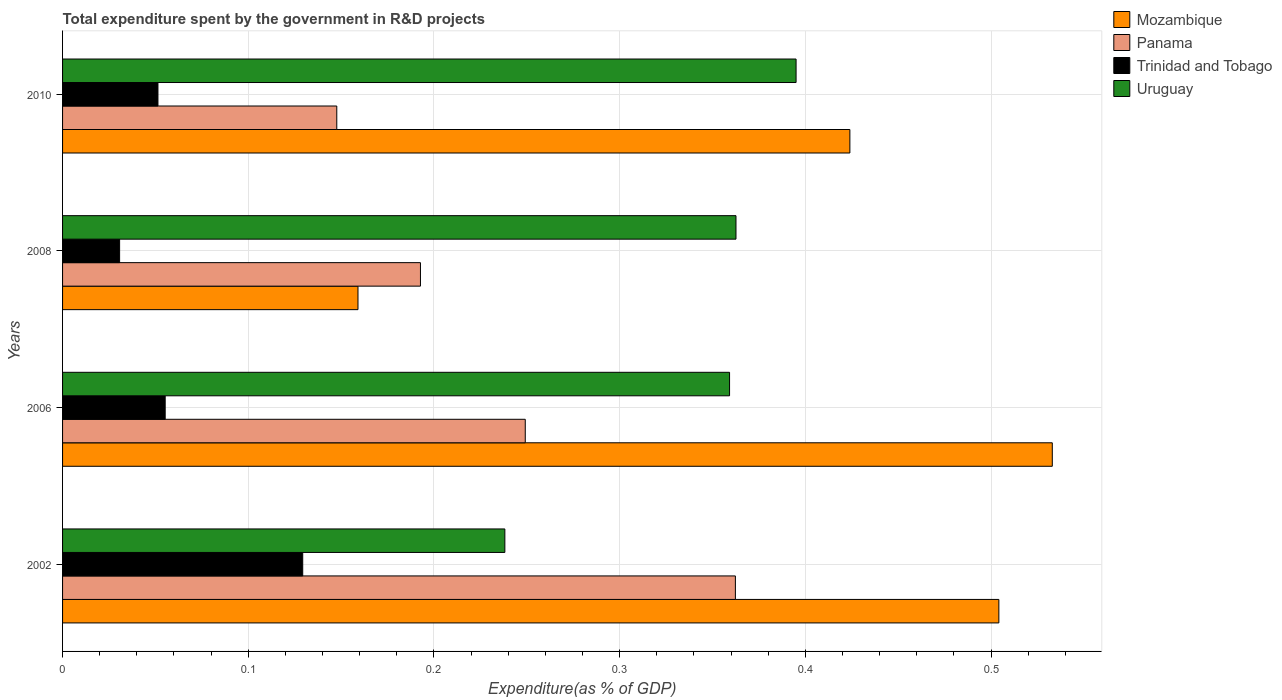How many different coloured bars are there?
Offer a very short reply. 4. Are the number of bars per tick equal to the number of legend labels?
Your response must be concise. Yes. How many bars are there on the 3rd tick from the top?
Offer a terse response. 4. How many bars are there on the 2nd tick from the bottom?
Provide a short and direct response. 4. What is the label of the 4th group of bars from the top?
Your answer should be compact. 2002. In how many cases, is the number of bars for a given year not equal to the number of legend labels?
Keep it short and to the point. 0. What is the total expenditure spent by the government in R&D projects in Mozambique in 2002?
Ensure brevity in your answer.  0.5. Across all years, what is the maximum total expenditure spent by the government in R&D projects in Trinidad and Tobago?
Keep it short and to the point. 0.13. Across all years, what is the minimum total expenditure spent by the government in R&D projects in Uruguay?
Your response must be concise. 0.24. In which year was the total expenditure spent by the government in R&D projects in Panama minimum?
Keep it short and to the point. 2010. What is the total total expenditure spent by the government in R&D projects in Trinidad and Tobago in the graph?
Your response must be concise. 0.27. What is the difference between the total expenditure spent by the government in R&D projects in Mozambique in 2002 and that in 2006?
Your answer should be compact. -0.03. What is the difference between the total expenditure spent by the government in R&D projects in Uruguay in 2010 and the total expenditure spent by the government in R&D projects in Mozambique in 2008?
Provide a succinct answer. 0.24. What is the average total expenditure spent by the government in R&D projects in Mozambique per year?
Offer a very short reply. 0.41. In the year 2008, what is the difference between the total expenditure spent by the government in R&D projects in Uruguay and total expenditure spent by the government in R&D projects in Panama?
Offer a terse response. 0.17. In how many years, is the total expenditure spent by the government in R&D projects in Panama greater than 0.06 %?
Your response must be concise. 4. What is the ratio of the total expenditure spent by the government in R&D projects in Mozambique in 2002 to that in 2010?
Give a very brief answer. 1.19. What is the difference between the highest and the second highest total expenditure spent by the government in R&D projects in Mozambique?
Make the answer very short. 0.03. What is the difference between the highest and the lowest total expenditure spent by the government in R&D projects in Uruguay?
Your answer should be very brief. 0.16. What does the 3rd bar from the top in 2002 represents?
Make the answer very short. Panama. What does the 2nd bar from the bottom in 2008 represents?
Your answer should be compact. Panama. How many bars are there?
Your answer should be very brief. 16. Are all the bars in the graph horizontal?
Your response must be concise. Yes. How many years are there in the graph?
Give a very brief answer. 4. What is the difference between two consecutive major ticks on the X-axis?
Provide a short and direct response. 0.1. Are the values on the major ticks of X-axis written in scientific E-notation?
Make the answer very short. No. Does the graph contain grids?
Your answer should be very brief. Yes. What is the title of the graph?
Keep it short and to the point. Total expenditure spent by the government in R&D projects. What is the label or title of the X-axis?
Your answer should be very brief. Expenditure(as % of GDP). What is the label or title of the Y-axis?
Ensure brevity in your answer.  Years. What is the Expenditure(as % of GDP) in Mozambique in 2002?
Keep it short and to the point. 0.5. What is the Expenditure(as % of GDP) of Panama in 2002?
Make the answer very short. 0.36. What is the Expenditure(as % of GDP) of Trinidad and Tobago in 2002?
Give a very brief answer. 0.13. What is the Expenditure(as % of GDP) of Uruguay in 2002?
Make the answer very short. 0.24. What is the Expenditure(as % of GDP) in Mozambique in 2006?
Make the answer very short. 0.53. What is the Expenditure(as % of GDP) of Panama in 2006?
Make the answer very short. 0.25. What is the Expenditure(as % of GDP) in Trinidad and Tobago in 2006?
Your response must be concise. 0.06. What is the Expenditure(as % of GDP) in Uruguay in 2006?
Offer a very short reply. 0.36. What is the Expenditure(as % of GDP) of Mozambique in 2008?
Make the answer very short. 0.16. What is the Expenditure(as % of GDP) of Panama in 2008?
Give a very brief answer. 0.19. What is the Expenditure(as % of GDP) of Trinidad and Tobago in 2008?
Make the answer very short. 0.03. What is the Expenditure(as % of GDP) of Uruguay in 2008?
Your response must be concise. 0.36. What is the Expenditure(as % of GDP) of Mozambique in 2010?
Provide a short and direct response. 0.42. What is the Expenditure(as % of GDP) in Panama in 2010?
Offer a terse response. 0.15. What is the Expenditure(as % of GDP) of Trinidad and Tobago in 2010?
Offer a very short reply. 0.05. What is the Expenditure(as % of GDP) of Uruguay in 2010?
Make the answer very short. 0.4. Across all years, what is the maximum Expenditure(as % of GDP) in Mozambique?
Your response must be concise. 0.53. Across all years, what is the maximum Expenditure(as % of GDP) in Panama?
Give a very brief answer. 0.36. Across all years, what is the maximum Expenditure(as % of GDP) in Trinidad and Tobago?
Give a very brief answer. 0.13. Across all years, what is the maximum Expenditure(as % of GDP) of Uruguay?
Provide a short and direct response. 0.4. Across all years, what is the minimum Expenditure(as % of GDP) of Mozambique?
Make the answer very short. 0.16. Across all years, what is the minimum Expenditure(as % of GDP) in Panama?
Keep it short and to the point. 0.15. Across all years, what is the minimum Expenditure(as % of GDP) in Trinidad and Tobago?
Provide a short and direct response. 0.03. Across all years, what is the minimum Expenditure(as % of GDP) in Uruguay?
Provide a short and direct response. 0.24. What is the total Expenditure(as % of GDP) of Mozambique in the graph?
Keep it short and to the point. 1.62. What is the total Expenditure(as % of GDP) of Panama in the graph?
Ensure brevity in your answer.  0.95. What is the total Expenditure(as % of GDP) of Trinidad and Tobago in the graph?
Offer a terse response. 0.27. What is the total Expenditure(as % of GDP) of Uruguay in the graph?
Give a very brief answer. 1.35. What is the difference between the Expenditure(as % of GDP) in Mozambique in 2002 and that in 2006?
Give a very brief answer. -0.03. What is the difference between the Expenditure(as % of GDP) of Panama in 2002 and that in 2006?
Your response must be concise. 0.11. What is the difference between the Expenditure(as % of GDP) in Trinidad and Tobago in 2002 and that in 2006?
Keep it short and to the point. 0.07. What is the difference between the Expenditure(as % of GDP) of Uruguay in 2002 and that in 2006?
Keep it short and to the point. -0.12. What is the difference between the Expenditure(as % of GDP) of Mozambique in 2002 and that in 2008?
Your answer should be very brief. 0.35. What is the difference between the Expenditure(as % of GDP) of Panama in 2002 and that in 2008?
Offer a very short reply. 0.17. What is the difference between the Expenditure(as % of GDP) in Trinidad and Tobago in 2002 and that in 2008?
Your answer should be compact. 0.1. What is the difference between the Expenditure(as % of GDP) of Uruguay in 2002 and that in 2008?
Your response must be concise. -0.12. What is the difference between the Expenditure(as % of GDP) in Mozambique in 2002 and that in 2010?
Make the answer very short. 0.08. What is the difference between the Expenditure(as % of GDP) in Panama in 2002 and that in 2010?
Provide a short and direct response. 0.21. What is the difference between the Expenditure(as % of GDP) in Trinidad and Tobago in 2002 and that in 2010?
Provide a short and direct response. 0.08. What is the difference between the Expenditure(as % of GDP) of Uruguay in 2002 and that in 2010?
Give a very brief answer. -0.16. What is the difference between the Expenditure(as % of GDP) in Mozambique in 2006 and that in 2008?
Make the answer very short. 0.37. What is the difference between the Expenditure(as % of GDP) in Panama in 2006 and that in 2008?
Provide a short and direct response. 0.06. What is the difference between the Expenditure(as % of GDP) of Trinidad and Tobago in 2006 and that in 2008?
Your response must be concise. 0.02. What is the difference between the Expenditure(as % of GDP) of Uruguay in 2006 and that in 2008?
Your answer should be compact. -0. What is the difference between the Expenditure(as % of GDP) in Mozambique in 2006 and that in 2010?
Your response must be concise. 0.11. What is the difference between the Expenditure(as % of GDP) of Panama in 2006 and that in 2010?
Offer a terse response. 0.1. What is the difference between the Expenditure(as % of GDP) of Trinidad and Tobago in 2006 and that in 2010?
Your response must be concise. 0. What is the difference between the Expenditure(as % of GDP) in Uruguay in 2006 and that in 2010?
Your response must be concise. -0.04. What is the difference between the Expenditure(as % of GDP) of Mozambique in 2008 and that in 2010?
Ensure brevity in your answer.  -0.26. What is the difference between the Expenditure(as % of GDP) in Panama in 2008 and that in 2010?
Provide a succinct answer. 0.05. What is the difference between the Expenditure(as % of GDP) in Trinidad and Tobago in 2008 and that in 2010?
Provide a succinct answer. -0.02. What is the difference between the Expenditure(as % of GDP) in Uruguay in 2008 and that in 2010?
Ensure brevity in your answer.  -0.03. What is the difference between the Expenditure(as % of GDP) of Mozambique in 2002 and the Expenditure(as % of GDP) of Panama in 2006?
Provide a short and direct response. 0.26. What is the difference between the Expenditure(as % of GDP) of Mozambique in 2002 and the Expenditure(as % of GDP) of Trinidad and Tobago in 2006?
Make the answer very short. 0.45. What is the difference between the Expenditure(as % of GDP) of Mozambique in 2002 and the Expenditure(as % of GDP) of Uruguay in 2006?
Your response must be concise. 0.14. What is the difference between the Expenditure(as % of GDP) of Panama in 2002 and the Expenditure(as % of GDP) of Trinidad and Tobago in 2006?
Provide a succinct answer. 0.31. What is the difference between the Expenditure(as % of GDP) in Panama in 2002 and the Expenditure(as % of GDP) in Uruguay in 2006?
Keep it short and to the point. 0. What is the difference between the Expenditure(as % of GDP) in Trinidad and Tobago in 2002 and the Expenditure(as % of GDP) in Uruguay in 2006?
Provide a succinct answer. -0.23. What is the difference between the Expenditure(as % of GDP) in Mozambique in 2002 and the Expenditure(as % of GDP) in Panama in 2008?
Offer a very short reply. 0.31. What is the difference between the Expenditure(as % of GDP) of Mozambique in 2002 and the Expenditure(as % of GDP) of Trinidad and Tobago in 2008?
Make the answer very short. 0.47. What is the difference between the Expenditure(as % of GDP) of Mozambique in 2002 and the Expenditure(as % of GDP) of Uruguay in 2008?
Your response must be concise. 0.14. What is the difference between the Expenditure(as % of GDP) of Panama in 2002 and the Expenditure(as % of GDP) of Trinidad and Tobago in 2008?
Your response must be concise. 0.33. What is the difference between the Expenditure(as % of GDP) in Panama in 2002 and the Expenditure(as % of GDP) in Uruguay in 2008?
Your answer should be very brief. -0. What is the difference between the Expenditure(as % of GDP) in Trinidad and Tobago in 2002 and the Expenditure(as % of GDP) in Uruguay in 2008?
Give a very brief answer. -0.23. What is the difference between the Expenditure(as % of GDP) of Mozambique in 2002 and the Expenditure(as % of GDP) of Panama in 2010?
Offer a very short reply. 0.36. What is the difference between the Expenditure(as % of GDP) of Mozambique in 2002 and the Expenditure(as % of GDP) of Trinidad and Tobago in 2010?
Make the answer very short. 0.45. What is the difference between the Expenditure(as % of GDP) of Mozambique in 2002 and the Expenditure(as % of GDP) of Uruguay in 2010?
Ensure brevity in your answer.  0.11. What is the difference between the Expenditure(as % of GDP) of Panama in 2002 and the Expenditure(as % of GDP) of Trinidad and Tobago in 2010?
Provide a short and direct response. 0.31. What is the difference between the Expenditure(as % of GDP) of Panama in 2002 and the Expenditure(as % of GDP) of Uruguay in 2010?
Ensure brevity in your answer.  -0.03. What is the difference between the Expenditure(as % of GDP) of Trinidad and Tobago in 2002 and the Expenditure(as % of GDP) of Uruguay in 2010?
Your answer should be compact. -0.27. What is the difference between the Expenditure(as % of GDP) in Mozambique in 2006 and the Expenditure(as % of GDP) in Panama in 2008?
Provide a short and direct response. 0.34. What is the difference between the Expenditure(as % of GDP) in Mozambique in 2006 and the Expenditure(as % of GDP) in Trinidad and Tobago in 2008?
Your answer should be very brief. 0.5. What is the difference between the Expenditure(as % of GDP) of Mozambique in 2006 and the Expenditure(as % of GDP) of Uruguay in 2008?
Keep it short and to the point. 0.17. What is the difference between the Expenditure(as % of GDP) in Panama in 2006 and the Expenditure(as % of GDP) in Trinidad and Tobago in 2008?
Provide a short and direct response. 0.22. What is the difference between the Expenditure(as % of GDP) of Panama in 2006 and the Expenditure(as % of GDP) of Uruguay in 2008?
Make the answer very short. -0.11. What is the difference between the Expenditure(as % of GDP) of Trinidad and Tobago in 2006 and the Expenditure(as % of GDP) of Uruguay in 2008?
Offer a very short reply. -0.31. What is the difference between the Expenditure(as % of GDP) of Mozambique in 2006 and the Expenditure(as % of GDP) of Panama in 2010?
Make the answer very short. 0.39. What is the difference between the Expenditure(as % of GDP) in Mozambique in 2006 and the Expenditure(as % of GDP) in Trinidad and Tobago in 2010?
Ensure brevity in your answer.  0.48. What is the difference between the Expenditure(as % of GDP) in Mozambique in 2006 and the Expenditure(as % of GDP) in Uruguay in 2010?
Give a very brief answer. 0.14. What is the difference between the Expenditure(as % of GDP) in Panama in 2006 and the Expenditure(as % of GDP) in Trinidad and Tobago in 2010?
Make the answer very short. 0.2. What is the difference between the Expenditure(as % of GDP) of Panama in 2006 and the Expenditure(as % of GDP) of Uruguay in 2010?
Keep it short and to the point. -0.15. What is the difference between the Expenditure(as % of GDP) of Trinidad and Tobago in 2006 and the Expenditure(as % of GDP) of Uruguay in 2010?
Your response must be concise. -0.34. What is the difference between the Expenditure(as % of GDP) in Mozambique in 2008 and the Expenditure(as % of GDP) in Panama in 2010?
Provide a succinct answer. 0.01. What is the difference between the Expenditure(as % of GDP) of Mozambique in 2008 and the Expenditure(as % of GDP) of Trinidad and Tobago in 2010?
Give a very brief answer. 0.11. What is the difference between the Expenditure(as % of GDP) in Mozambique in 2008 and the Expenditure(as % of GDP) in Uruguay in 2010?
Provide a succinct answer. -0.24. What is the difference between the Expenditure(as % of GDP) in Panama in 2008 and the Expenditure(as % of GDP) in Trinidad and Tobago in 2010?
Provide a short and direct response. 0.14. What is the difference between the Expenditure(as % of GDP) in Panama in 2008 and the Expenditure(as % of GDP) in Uruguay in 2010?
Offer a very short reply. -0.2. What is the difference between the Expenditure(as % of GDP) of Trinidad and Tobago in 2008 and the Expenditure(as % of GDP) of Uruguay in 2010?
Give a very brief answer. -0.36. What is the average Expenditure(as % of GDP) in Mozambique per year?
Ensure brevity in your answer.  0.41. What is the average Expenditure(as % of GDP) in Panama per year?
Make the answer very short. 0.24. What is the average Expenditure(as % of GDP) of Trinidad and Tobago per year?
Make the answer very short. 0.07. What is the average Expenditure(as % of GDP) in Uruguay per year?
Ensure brevity in your answer.  0.34. In the year 2002, what is the difference between the Expenditure(as % of GDP) of Mozambique and Expenditure(as % of GDP) of Panama?
Make the answer very short. 0.14. In the year 2002, what is the difference between the Expenditure(as % of GDP) in Mozambique and Expenditure(as % of GDP) in Trinidad and Tobago?
Your answer should be compact. 0.37. In the year 2002, what is the difference between the Expenditure(as % of GDP) of Mozambique and Expenditure(as % of GDP) of Uruguay?
Give a very brief answer. 0.27. In the year 2002, what is the difference between the Expenditure(as % of GDP) in Panama and Expenditure(as % of GDP) in Trinidad and Tobago?
Keep it short and to the point. 0.23. In the year 2002, what is the difference between the Expenditure(as % of GDP) of Panama and Expenditure(as % of GDP) of Uruguay?
Offer a terse response. 0.12. In the year 2002, what is the difference between the Expenditure(as % of GDP) in Trinidad and Tobago and Expenditure(as % of GDP) in Uruguay?
Keep it short and to the point. -0.11. In the year 2006, what is the difference between the Expenditure(as % of GDP) of Mozambique and Expenditure(as % of GDP) of Panama?
Give a very brief answer. 0.28. In the year 2006, what is the difference between the Expenditure(as % of GDP) of Mozambique and Expenditure(as % of GDP) of Trinidad and Tobago?
Offer a terse response. 0.48. In the year 2006, what is the difference between the Expenditure(as % of GDP) of Mozambique and Expenditure(as % of GDP) of Uruguay?
Your response must be concise. 0.17. In the year 2006, what is the difference between the Expenditure(as % of GDP) in Panama and Expenditure(as % of GDP) in Trinidad and Tobago?
Your response must be concise. 0.19. In the year 2006, what is the difference between the Expenditure(as % of GDP) in Panama and Expenditure(as % of GDP) in Uruguay?
Your response must be concise. -0.11. In the year 2006, what is the difference between the Expenditure(as % of GDP) of Trinidad and Tobago and Expenditure(as % of GDP) of Uruguay?
Ensure brevity in your answer.  -0.3. In the year 2008, what is the difference between the Expenditure(as % of GDP) in Mozambique and Expenditure(as % of GDP) in Panama?
Give a very brief answer. -0.03. In the year 2008, what is the difference between the Expenditure(as % of GDP) of Mozambique and Expenditure(as % of GDP) of Trinidad and Tobago?
Give a very brief answer. 0.13. In the year 2008, what is the difference between the Expenditure(as % of GDP) in Mozambique and Expenditure(as % of GDP) in Uruguay?
Ensure brevity in your answer.  -0.2. In the year 2008, what is the difference between the Expenditure(as % of GDP) in Panama and Expenditure(as % of GDP) in Trinidad and Tobago?
Give a very brief answer. 0.16. In the year 2008, what is the difference between the Expenditure(as % of GDP) in Panama and Expenditure(as % of GDP) in Uruguay?
Your answer should be compact. -0.17. In the year 2008, what is the difference between the Expenditure(as % of GDP) in Trinidad and Tobago and Expenditure(as % of GDP) in Uruguay?
Offer a very short reply. -0.33. In the year 2010, what is the difference between the Expenditure(as % of GDP) of Mozambique and Expenditure(as % of GDP) of Panama?
Your answer should be very brief. 0.28. In the year 2010, what is the difference between the Expenditure(as % of GDP) in Mozambique and Expenditure(as % of GDP) in Trinidad and Tobago?
Offer a very short reply. 0.37. In the year 2010, what is the difference between the Expenditure(as % of GDP) in Mozambique and Expenditure(as % of GDP) in Uruguay?
Your answer should be compact. 0.03. In the year 2010, what is the difference between the Expenditure(as % of GDP) in Panama and Expenditure(as % of GDP) in Trinidad and Tobago?
Offer a terse response. 0.1. In the year 2010, what is the difference between the Expenditure(as % of GDP) of Panama and Expenditure(as % of GDP) of Uruguay?
Your answer should be compact. -0.25. In the year 2010, what is the difference between the Expenditure(as % of GDP) of Trinidad and Tobago and Expenditure(as % of GDP) of Uruguay?
Your answer should be compact. -0.34. What is the ratio of the Expenditure(as % of GDP) of Mozambique in 2002 to that in 2006?
Keep it short and to the point. 0.95. What is the ratio of the Expenditure(as % of GDP) in Panama in 2002 to that in 2006?
Provide a succinct answer. 1.45. What is the ratio of the Expenditure(as % of GDP) of Trinidad and Tobago in 2002 to that in 2006?
Your response must be concise. 2.34. What is the ratio of the Expenditure(as % of GDP) of Uruguay in 2002 to that in 2006?
Make the answer very short. 0.66. What is the ratio of the Expenditure(as % of GDP) in Mozambique in 2002 to that in 2008?
Provide a short and direct response. 3.17. What is the ratio of the Expenditure(as % of GDP) of Panama in 2002 to that in 2008?
Your answer should be very brief. 1.88. What is the ratio of the Expenditure(as % of GDP) of Trinidad and Tobago in 2002 to that in 2008?
Ensure brevity in your answer.  4.21. What is the ratio of the Expenditure(as % of GDP) in Uruguay in 2002 to that in 2008?
Give a very brief answer. 0.66. What is the ratio of the Expenditure(as % of GDP) in Mozambique in 2002 to that in 2010?
Your answer should be very brief. 1.19. What is the ratio of the Expenditure(as % of GDP) in Panama in 2002 to that in 2010?
Keep it short and to the point. 2.45. What is the ratio of the Expenditure(as % of GDP) in Trinidad and Tobago in 2002 to that in 2010?
Keep it short and to the point. 2.52. What is the ratio of the Expenditure(as % of GDP) in Uruguay in 2002 to that in 2010?
Make the answer very short. 0.6. What is the ratio of the Expenditure(as % of GDP) in Mozambique in 2006 to that in 2008?
Offer a very short reply. 3.35. What is the ratio of the Expenditure(as % of GDP) of Panama in 2006 to that in 2008?
Offer a very short reply. 1.29. What is the ratio of the Expenditure(as % of GDP) of Trinidad and Tobago in 2006 to that in 2008?
Your answer should be compact. 1.8. What is the ratio of the Expenditure(as % of GDP) of Mozambique in 2006 to that in 2010?
Your response must be concise. 1.26. What is the ratio of the Expenditure(as % of GDP) of Panama in 2006 to that in 2010?
Your answer should be very brief. 1.69. What is the ratio of the Expenditure(as % of GDP) of Trinidad and Tobago in 2006 to that in 2010?
Offer a very short reply. 1.08. What is the ratio of the Expenditure(as % of GDP) of Uruguay in 2006 to that in 2010?
Provide a short and direct response. 0.91. What is the ratio of the Expenditure(as % of GDP) of Mozambique in 2008 to that in 2010?
Provide a succinct answer. 0.38. What is the ratio of the Expenditure(as % of GDP) in Panama in 2008 to that in 2010?
Give a very brief answer. 1.31. What is the ratio of the Expenditure(as % of GDP) of Trinidad and Tobago in 2008 to that in 2010?
Your answer should be compact. 0.6. What is the ratio of the Expenditure(as % of GDP) in Uruguay in 2008 to that in 2010?
Your answer should be very brief. 0.92. What is the difference between the highest and the second highest Expenditure(as % of GDP) of Mozambique?
Keep it short and to the point. 0.03. What is the difference between the highest and the second highest Expenditure(as % of GDP) in Panama?
Keep it short and to the point. 0.11. What is the difference between the highest and the second highest Expenditure(as % of GDP) of Trinidad and Tobago?
Your answer should be very brief. 0.07. What is the difference between the highest and the second highest Expenditure(as % of GDP) of Uruguay?
Make the answer very short. 0.03. What is the difference between the highest and the lowest Expenditure(as % of GDP) of Mozambique?
Ensure brevity in your answer.  0.37. What is the difference between the highest and the lowest Expenditure(as % of GDP) in Panama?
Your answer should be very brief. 0.21. What is the difference between the highest and the lowest Expenditure(as % of GDP) in Trinidad and Tobago?
Make the answer very short. 0.1. What is the difference between the highest and the lowest Expenditure(as % of GDP) in Uruguay?
Offer a terse response. 0.16. 